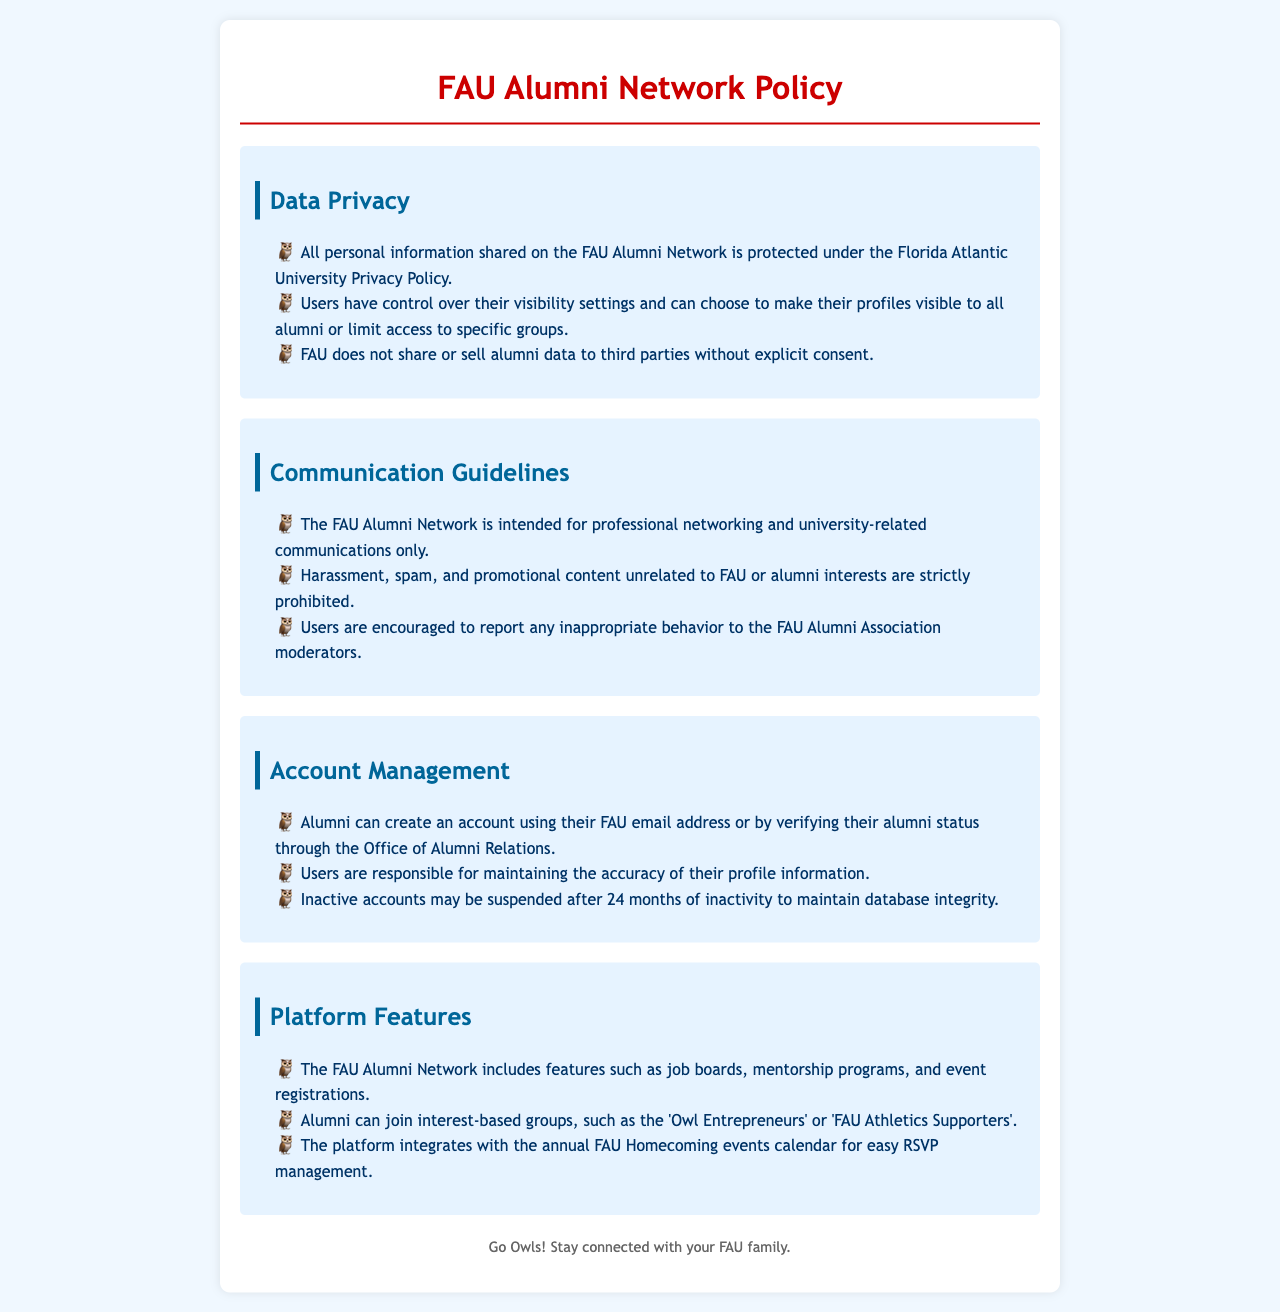What is the main purpose of the FAU Alumni Network? The main purpose is for professional networking and university-related communications only.
Answer: Professional networking What are users encouraged to report? Users are encouraged to report any inappropriate behavior to the FAU Alumni Association moderators.
Answer: Inappropriate behavior How long may inactive accounts be suspended? Inactive accounts may be suspended after a period of 24 months of inactivity.
Answer: 24 months Are users allowed to share their personal information with third parties? FAU does not share or sell alumni data to third parties without explicit consent.
Answer: No What types of groups can alumni join on the platform? Alumni can join interest-based groups such as 'Owl Entrepreneurs' or 'FAU Athletics Supporters'.
Answer: Interest-based groups What controls do users have over their profile visibility? Users have control over their visibility settings and can choose to make their profiles visible to all alumni or limit access to specific groups.
Answer: Visibility settings What is required to create an account on the platform? Alumni can create an account using their FAU email address or by verifying their alumni status through the Office of Alumni Relations.
Answer: FAU email address or verification What types of features does the FAU Alumni Network include? The FAU Alumni Network includes features such as job boards, mentorship programs, and event registrations.
Answer: Job boards, mentorship programs, event registrations Which policy protects personal information shared on the FAU Alumni Network? All personal information shared on the FAU Alumni Network is protected under the Florida Atlantic University Privacy Policy.
Answer: Florida Atlantic University Privacy Policy 